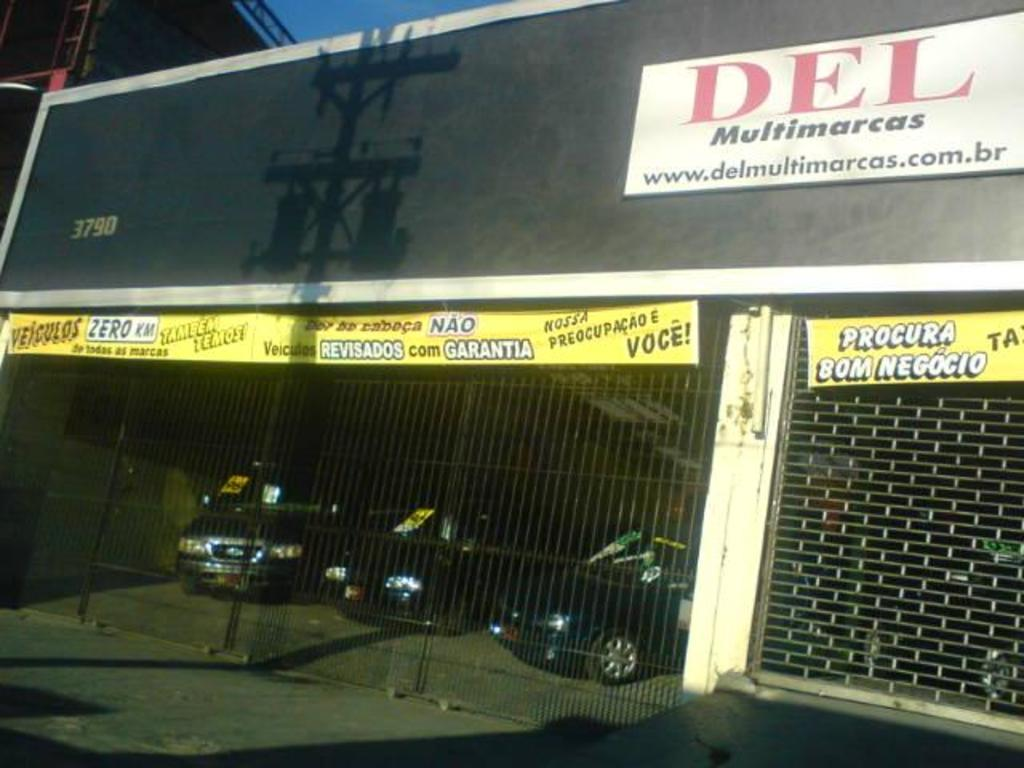What is the primary object in the image? There is a name board in the image. What else can be seen in the image besides the name board? There are banners, a shutter, vehicles on the ground, a fence, and some objects in the image. Can you describe the vehicles in the image? The vehicles on the ground are not specified, but they are present in the image. What type of barrier is visible in the image? There is a fence in the image. How does the person in the image express their hate towards the cap? There is no person or cap present in the image, so it is not possible to determine any expression of hate. 